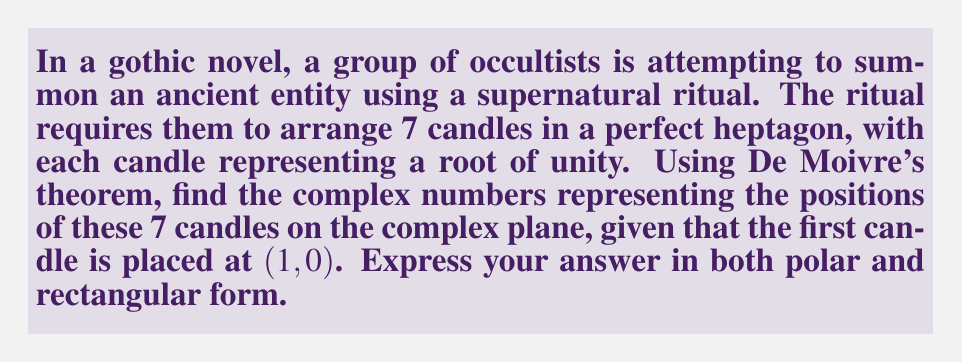Could you help me with this problem? To solve this problem, we'll use De Moivre's theorem to find the 7th roots of unity. The process is as follows:

1) The general formula for the nth roots of unity is:

   $$z_k = e^{i(2\pi k/n)} = \cos(2\pi k/n) + i\sin(2\pi k/n)$$

   where $k = 0, 1, 2, ..., n-1$

2) In this case, $n = 7$, so we need to find:

   $$z_k = e^{i(2\pi k/7)} = \cos(2\pi k/7) + i\sin(2\pi k/7)$$

   for $k = 0, 1, 2, 3, 4, 5, 6$

3) Let's calculate each root:

   For $k = 0$: $z_0 = e^{i(0)} = 1 + 0i = 1$ (This is the first candle at $(1,0)$)
   
   For $k = 1$: $z_1 = e^{i(2\pi/7)} = \cos(2\pi/7) + i\sin(2\pi/7)$
   
   For $k = 2$: $z_2 = e^{i(4\pi/7)} = \cos(4\pi/7) + i\sin(4\pi/7)$
   
   For $k = 3$: $z_3 = e^{i(6\pi/7)} = \cos(6\pi/7) + i\sin(6\pi/7)$
   
   For $k = 4$: $z_4 = e^{i(8\pi/7)} = \cos(8\pi/7) + i\sin(8\pi/7)$
   
   For $k = 5$: $z_5 = e^{i(10\pi/7)} = \cos(10\pi/7) + i\sin(10\pi/7)$
   
   For $k = 6$: $z_6 = e^{i(12\pi/7)} = \cos(12\pi/7) + i\sin(12\pi/7)$

4) These complex numbers represent the positions of the candles on the complex plane, both in polar form $(e^{i\theta})$ and rectangular form $(a + bi)$.
Answer: The 7 roots of unity representing the candle positions are:

$z_0 = e^{i(0)} = 1 + 0i = 1$

$z_1 = e^{i(2\pi/7)} \approx 0.6235 + 0.7818i$

$z_2 = e^{i(4\pi/7)} \approx -0.2225 + 0.9749i$

$z_3 = e^{i(6\pi/7)} \approx -0.9010 + 0.4339i$

$z_4 = e^{i(8\pi/7)} \approx -0.9010 - 0.4339i$

$z_5 = e^{i(10\pi/7)} \approx -0.2225 - 0.9749i$

$z_6 = e^{i(12\pi/7)} \approx 0.6235 - 0.7818i$ 